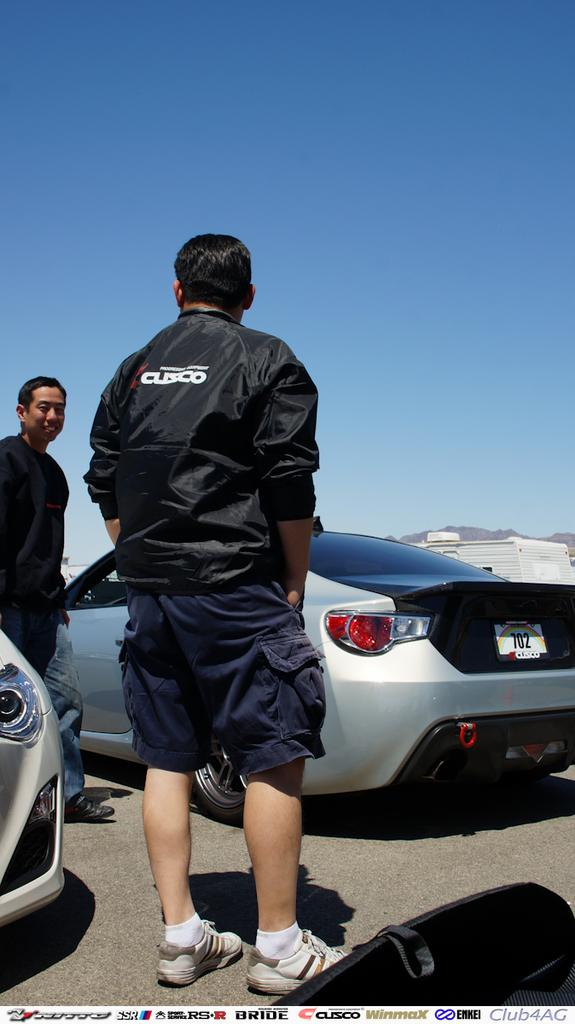What can be seen in the image in terms of people? There are men standing in the image. What type of transportation is visible in the image? There are cars parked in the image. Can you describe the vehicles in the image? There are vehicles parked on the side in the image. What is the color of the sky in the image? The sky is blue in the image. What type of cork can be seen in the image? There is no cork present in the image. What does the caption say about the image? There is no caption provided with the image. 